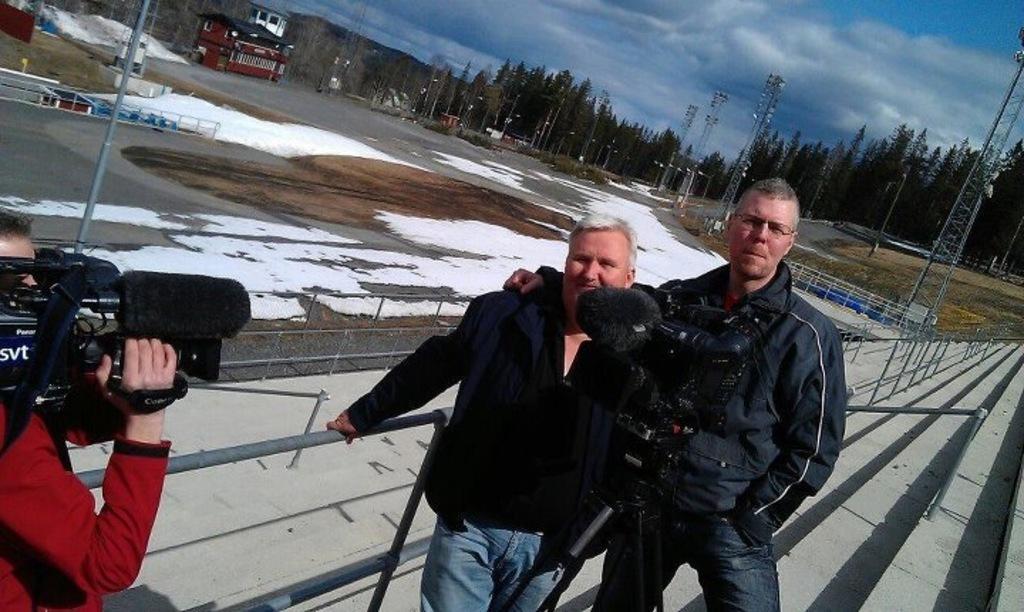Could you give a brief overview of what you see in this image? In this image, in the middle, we can see two men wearing a black color shirt is standing in front of a camera. On the left side, we can also see a person wearing a red color shirt is holding a camera in his hand. On the right side, we can also see a tower, plants. In the background, we can see a pole, electric pole, wires, trees, houses. At the top, we can see a sky which is a bit cloudy, at the bottom, we can see a snow and a land. 